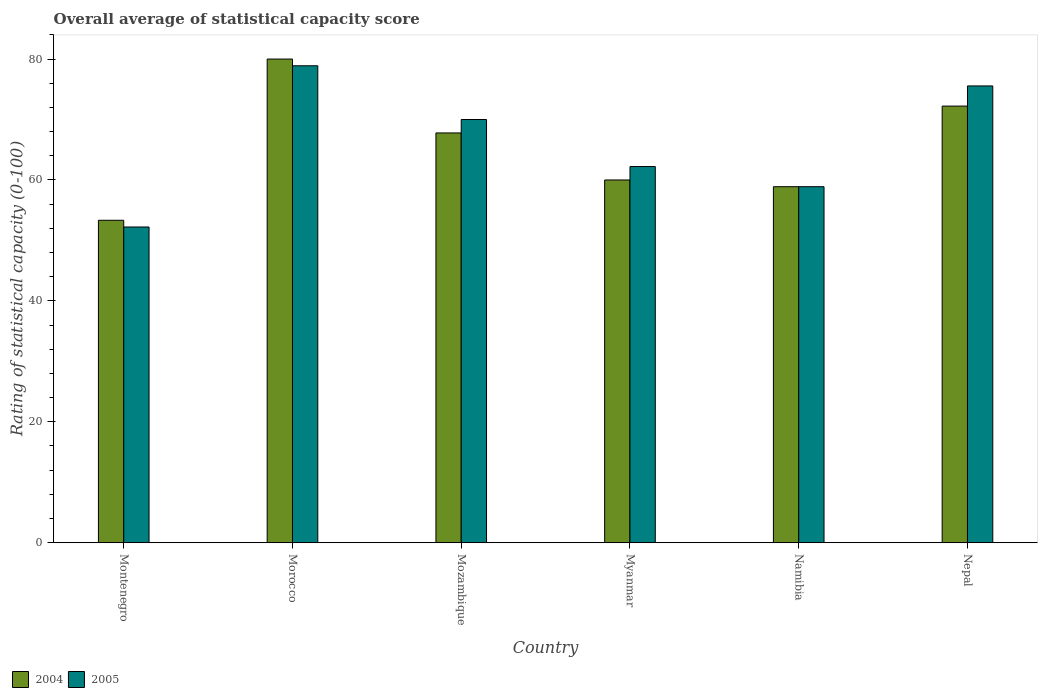How many groups of bars are there?
Keep it short and to the point. 6. How many bars are there on the 1st tick from the left?
Make the answer very short. 2. How many bars are there on the 3rd tick from the right?
Your response must be concise. 2. What is the label of the 3rd group of bars from the left?
Make the answer very short. Mozambique. What is the rating of statistical capacity in 2004 in Myanmar?
Your answer should be compact. 60. Across all countries, what is the maximum rating of statistical capacity in 2005?
Provide a succinct answer. 78.89. Across all countries, what is the minimum rating of statistical capacity in 2005?
Your response must be concise. 52.22. In which country was the rating of statistical capacity in 2005 maximum?
Offer a terse response. Morocco. In which country was the rating of statistical capacity in 2004 minimum?
Your answer should be very brief. Montenegro. What is the total rating of statistical capacity in 2005 in the graph?
Your answer should be very brief. 397.78. What is the difference between the rating of statistical capacity in 2004 in Myanmar and that in Namibia?
Ensure brevity in your answer.  1.11. What is the difference between the rating of statistical capacity in 2004 in Morocco and the rating of statistical capacity in 2005 in Nepal?
Offer a terse response. 4.44. What is the average rating of statistical capacity in 2005 per country?
Offer a very short reply. 66.3. What is the difference between the rating of statistical capacity of/in 2004 and rating of statistical capacity of/in 2005 in Montenegro?
Keep it short and to the point. 1.11. In how many countries, is the rating of statistical capacity in 2005 greater than 4?
Provide a succinct answer. 6. What is the ratio of the rating of statistical capacity in 2004 in Morocco to that in Mozambique?
Provide a short and direct response. 1.18. Is the rating of statistical capacity in 2004 in Namibia less than that in Nepal?
Your answer should be very brief. Yes. Is the difference between the rating of statistical capacity in 2004 in Montenegro and Morocco greater than the difference between the rating of statistical capacity in 2005 in Montenegro and Morocco?
Your response must be concise. No. What is the difference between the highest and the second highest rating of statistical capacity in 2005?
Ensure brevity in your answer.  -5.56. What is the difference between the highest and the lowest rating of statistical capacity in 2004?
Provide a succinct answer. 26.67. What does the 1st bar from the left in Myanmar represents?
Offer a terse response. 2004. What does the 1st bar from the right in Namibia represents?
Your answer should be compact. 2005. Are all the bars in the graph horizontal?
Provide a short and direct response. No. Does the graph contain grids?
Your answer should be very brief. No. Where does the legend appear in the graph?
Your answer should be very brief. Bottom left. How are the legend labels stacked?
Make the answer very short. Horizontal. What is the title of the graph?
Give a very brief answer. Overall average of statistical capacity score. What is the label or title of the Y-axis?
Provide a succinct answer. Rating of statistical capacity (0-100). What is the Rating of statistical capacity (0-100) of 2004 in Montenegro?
Ensure brevity in your answer.  53.33. What is the Rating of statistical capacity (0-100) in 2005 in Montenegro?
Your response must be concise. 52.22. What is the Rating of statistical capacity (0-100) in 2005 in Morocco?
Offer a very short reply. 78.89. What is the Rating of statistical capacity (0-100) of 2004 in Mozambique?
Ensure brevity in your answer.  67.78. What is the Rating of statistical capacity (0-100) in 2005 in Mozambique?
Offer a terse response. 70. What is the Rating of statistical capacity (0-100) of 2004 in Myanmar?
Make the answer very short. 60. What is the Rating of statistical capacity (0-100) in 2005 in Myanmar?
Provide a succinct answer. 62.22. What is the Rating of statistical capacity (0-100) of 2004 in Namibia?
Keep it short and to the point. 58.89. What is the Rating of statistical capacity (0-100) of 2005 in Namibia?
Your response must be concise. 58.89. What is the Rating of statistical capacity (0-100) in 2004 in Nepal?
Your response must be concise. 72.22. What is the Rating of statistical capacity (0-100) of 2005 in Nepal?
Your response must be concise. 75.56. Across all countries, what is the maximum Rating of statistical capacity (0-100) in 2004?
Make the answer very short. 80. Across all countries, what is the maximum Rating of statistical capacity (0-100) of 2005?
Offer a terse response. 78.89. Across all countries, what is the minimum Rating of statistical capacity (0-100) of 2004?
Offer a very short reply. 53.33. Across all countries, what is the minimum Rating of statistical capacity (0-100) of 2005?
Offer a terse response. 52.22. What is the total Rating of statistical capacity (0-100) in 2004 in the graph?
Your response must be concise. 392.22. What is the total Rating of statistical capacity (0-100) in 2005 in the graph?
Provide a succinct answer. 397.78. What is the difference between the Rating of statistical capacity (0-100) in 2004 in Montenegro and that in Morocco?
Give a very brief answer. -26.67. What is the difference between the Rating of statistical capacity (0-100) in 2005 in Montenegro and that in Morocco?
Provide a short and direct response. -26.67. What is the difference between the Rating of statistical capacity (0-100) of 2004 in Montenegro and that in Mozambique?
Provide a short and direct response. -14.44. What is the difference between the Rating of statistical capacity (0-100) in 2005 in Montenegro and that in Mozambique?
Ensure brevity in your answer.  -17.78. What is the difference between the Rating of statistical capacity (0-100) of 2004 in Montenegro and that in Myanmar?
Your response must be concise. -6.67. What is the difference between the Rating of statistical capacity (0-100) in 2005 in Montenegro and that in Myanmar?
Provide a short and direct response. -10. What is the difference between the Rating of statistical capacity (0-100) in 2004 in Montenegro and that in Namibia?
Keep it short and to the point. -5.56. What is the difference between the Rating of statistical capacity (0-100) in 2005 in Montenegro and that in Namibia?
Provide a succinct answer. -6.67. What is the difference between the Rating of statistical capacity (0-100) in 2004 in Montenegro and that in Nepal?
Give a very brief answer. -18.89. What is the difference between the Rating of statistical capacity (0-100) in 2005 in Montenegro and that in Nepal?
Your answer should be very brief. -23.33. What is the difference between the Rating of statistical capacity (0-100) of 2004 in Morocco and that in Mozambique?
Your answer should be compact. 12.22. What is the difference between the Rating of statistical capacity (0-100) in 2005 in Morocco and that in Mozambique?
Your answer should be compact. 8.89. What is the difference between the Rating of statistical capacity (0-100) of 2005 in Morocco and that in Myanmar?
Give a very brief answer. 16.67. What is the difference between the Rating of statistical capacity (0-100) in 2004 in Morocco and that in Namibia?
Make the answer very short. 21.11. What is the difference between the Rating of statistical capacity (0-100) of 2004 in Morocco and that in Nepal?
Offer a terse response. 7.78. What is the difference between the Rating of statistical capacity (0-100) of 2005 in Morocco and that in Nepal?
Ensure brevity in your answer.  3.33. What is the difference between the Rating of statistical capacity (0-100) in 2004 in Mozambique and that in Myanmar?
Ensure brevity in your answer.  7.78. What is the difference between the Rating of statistical capacity (0-100) of 2005 in Mozambique and that in Myanmar?
Provide a succinct answer. 7.78. What is the difference between the Rating of statistical capacity (0-100) of 2004 in Mozambique and that in Namibia?
Make the answer very short. 8.89. What is the difference between the Rating of statistical capacity (0-100) of 2005 in Mozambique and that in Namibia?
Your response must be concise. 11.11. What is the difference between the Rating of statistical capacity (0-100) of 2004 in Mozambique and that in Nepal?
Make the answer very short. -4.44. What is the difference between the Rating of statistical capacity (0-100) of 2005 in Mozambique and that in Nepal?
Your answer should be compact. -5.56. What is the difference between the Rating of statistical capacity (0-100) of 2005 in Myanmar and that in Namibia?
Offer a very short reply. 3.33. What is the difference between the Rating of statistical capacity (0-100) in 2004 in Myanmar and that in Nepal?
Make the answer very short. -12.22. What is the difference between the Rating of statistical capacity (0-100) of 2005 in Myanmar and that in Nepal?
Give a very brief answer. -13.33. What is the difference between the Rating of statistical capacity (0-100) of 2004 in Namibia and that in Nepal?
Provide a short and direct response. -13.33. What is the difference between the Rating of statistical capacity (0-100) of 2005 in Namibia and that in Nepal?
Keep it short and to the point. -16.67. What is the difference between the Rating of statistical capacity (0-100) in 2004 in Montenegro and the Rating of statistical capacity (0-100) in 2005 in Morocco?
Provide a short and direct response. -25.56. What is the difference between the Rating of statistical capacity (0-100) in 2004 in Montenegro and the Rating of statistical capacity (0-100) in 2005 in Mozambique?
Keep it short and to the point. -16.67. What is the difference between the Rating of statistical capacity (0-100) of 2004 in Montenegro and the Rating of statistical capacity (0-100) of 2005 in Myanmar?
Provide a succinct answer. -8.89. What is the difference between the Rating of statistical capacity (0-100) in 2004 in Montenegro and the Rating of statistical capacity (0-100) in 2005 in Namibia?
Offer a terse response. -5.56. What is the difference between the Rating of statistical capacity (0-100) in 2004 in Montenegro and the Rating of statistical capacity (0-100) in 2005 in Nepal?
Ensure brevity in your answer.  -22.22. What is the difference between the Rating of statistical capacity (0-100) of 2004 in Morocco and the Rating of statistical capacity (0-100) of 2005 in Myanmar?
Your answer should be compact. 17.78. What is the difference between the Rating of statistical capacity (0-100) in 2004 in Morocco and the Rating of statistical capacity (0-100) in 2005 in Namibia?
Offer a very short reply. 21.11. What is the difference between the Rating of statistical capacity (0-100) of 2004 in Morocco and the Rating of statistical capacity (0-100) of 2005 in Nepal?
Ensure brevity in your answer.  4.44. What is the difference between the Rating of statistical capacity (0-100) in 2004 in Mozambique and the Rating of statistical capacity (0-100) in 2005 in Myanmar?
Your answer should be very brief. 5.56. What is the difference between the Rating of statistical capacity (0-100) of 2004 in Mozambique and the Rating of statistical capacity (0-100) of 2005 in Namibia?
Your answer should be compact. 8.89. What is the difference between the Rating of statistical capacity (0-100) in 2004 in Mozambique and the Rating of statistical capacity (0-100) in 2005 in Nepal?
Your response must be concise. -7.78. What is the difference between the Rating of statistical capacity (0-100) in 2004 in Myanmar and the Rating of statistical capacity (0-100) in 2005 in Nepal?
Make the answer very short. -15.56. What is the difference between the Rating of statistical capacity (0-100) of 2004 in Namibia and the Rating of statistical capacity (0-100) of 2005 in Nepal?
Your answer should be very brief. -16.67. What is the average Rating of statistical capacity (0-100) in 2004 per country?
Your answer should be compact. 65.37. What is the average Rating of statistical capacity (0-100) of 2005 per country?
Offer a very short reply. 66.3. What is the difference between the Rating of statistical capacity (0-100) in 2004 and Rating of statistical capacity (0-100) in 2005 in Montenegro?
Keep it short and to the point. 1.11. What is the difference between the Rating of statistical capacity (0-100) in 2004 and Rating of statistical capacity (0-100) in 2005 in Mozambique?
Your answer should be compact. -2.22. What is the difference between the Rating of statistical capacity (0-100) in 2004 and Rating of statistical capacity (0-100) in 2005 in Myanmar?
Give a very brief answer. -2.22. What is the difference between the Rating of statistical capacity (0-100) in 2004 and Rating of statistical capacity (0-100) in 2005 in Namibia?
Your answer should be compact. 0. What is the difference between the Rating of statistical capacity (0-100) in 2004 and Rating of statistical capacity (0-100) in 2005 in Nepal?
Provide a short and direct response. -3.33. What is the ratio of the Rating of statistical capacity (0-100) in 2005 in Montenegro to that in Morocco?
Provide a succinct answer. 0.66. What is the ratio of the Rating of statistical capacity (0-100) in 2004 in Montenegro to that in Mozambique?
Offer a terse response. 0.79. What is the ratio of the Rating of statistical capacity (0-100) of 2005 in Montenegro to that in Mozambique?
Make the answer very short. 0.75. What is the ratio of the Rating of statistical capacity (0-100) in 2004 in Montenegro to that in Myanmar?
Your response must be concise. 0.89. What is the ratio of the Rating of statistical capacity (0-100) of 2005 in Montenegro to that in Myanmar?
Provide a succinct answer. 0.84. What is the ratio of the Rating of statistical capacity (0-100) in 2004 in Montenegro to that in Namibia?
Offer a terse response. 0.91. What is the ratio of the Rating of statistical capacity (0-100) in 2005 in Montenegro to that in Namibia?
Provide a succinct answer. 0.89. What is the ratio of the Rating of statistical capacity (0-100) of 2004 in Montenegro to that in Nepal?
Keep it short and to the point. 0.74. What is the ratio of the Rating of statistical capacity (0-100) in 2005 in Montenegro to that in Nepal?
Your response must be concise. 0.69. What is the ratio of the Rating of statistical capacity (0-100) in 2004 in Morocco to that in Mozambique?
Your answer should be very brief. 1.18. What is the ratio of the Rating of statistical capacity (0-100) of 2005 in Morocco to that in Mozambique?
Your answer should be very brief. 1.13. What is the ratio of the Rating of statistical capacity (0-100) of 2005 in Morocco to that in Myanmar?
Keep it short and to the point. 1.27. What is the ratio of the Rating of statistical capacity (0-100) in 2004 in Morocco to that in Namibia?
Offer a very short reply. 1.36. What is the ratio of the Rating of statistical capacity (0-100) in 2005 in Morocco to that in Namibia?
Your response must be concise. 1.34. What is the ratio of the Rating of statistical capacity (0-100) in 2004 in Morocco to that in Nepal?
Keep it short and to the point. 1.11. What is the ratio of the Rating of statistical capacity (0-100) in 2005 in Morocco to that in Nepal?
Offer a terse response. 1.04. What is the ratio of the Rating of statistical capacity (0-100) in 2004 in Mozambique to that in Myanmar?
Make the answer very short. 1.13. What is the ratio of the Rating of statistical capacity (0-100) in 2005 in Mozambique to that in Myanmar?
Your response must be concise. 1.12. What is the ratio of the Rating of statistical capacity (0-100) in 2004 in Mozambique to that in Namibia?
Give a very brief answer. 1.15. What is the ratio of the Rating of statistical capacity (0-100) of 2005 in Mozambique to that in Namibia?
Give a very brief answer. 1.19. What is the ratio of the Rating of statistical capacity (0-100) in 2004 in Mozambique to that in Nepal?
Your answer should be very brief. 0.94. What is the ratio of the Rating of statistical capacity (0-100) of 2005 in Mozambique to that in Nepal?
Offer a very short reply. 0.93. What is the ratio of the Rating of statistical capacity (0-100) of 2004 in Myanmar to that in Namibia?
Your response must be concise. 1.02. What is the ratio of the Rating of statistical capacity (0-100) of 2005 in Myanmar to that in Namibia?
Offer a very short reply. 1.06. What is the ratio of the Rating of statistical capacity (0-100) in 2004 in Myanmar to that in Nepal?
Ensure brevity in your answer.  0.83. What is the ratio of the Rating of statistical capacity (0-100) of 2005 in Myanmar to that in Nepal?
Provide a succinct answer. 0.82. What is the ratio of the Rating of statistical capacity (0-100) in 2004 in Namibia to that in Nepal?
Provide a succinct answer. 0.82. What is the ratio of the Rating of statistical capacity (0-100) of 2005 in Namibia to that in Nepal?
Offer a very short reply. 0.78. What is the difference between the highest and the second highest Rating of statistical capacity (0-100) in 2004?
Provide a short and direct response. 7.78. What is the difference between the highest and the second highest Rating of statistical capacity (0-100) in 2005?
Your response must be concise. 3.33. What is the difference between the highest and the lowest Rating of statistical capacity (0-100) of 2004?
Keep it short and to the point. 26.67. What is the difference between the highest and the lowest Rating of statistical capacity (0-100) of 2005?
Your answer should be compact. 26.67. 